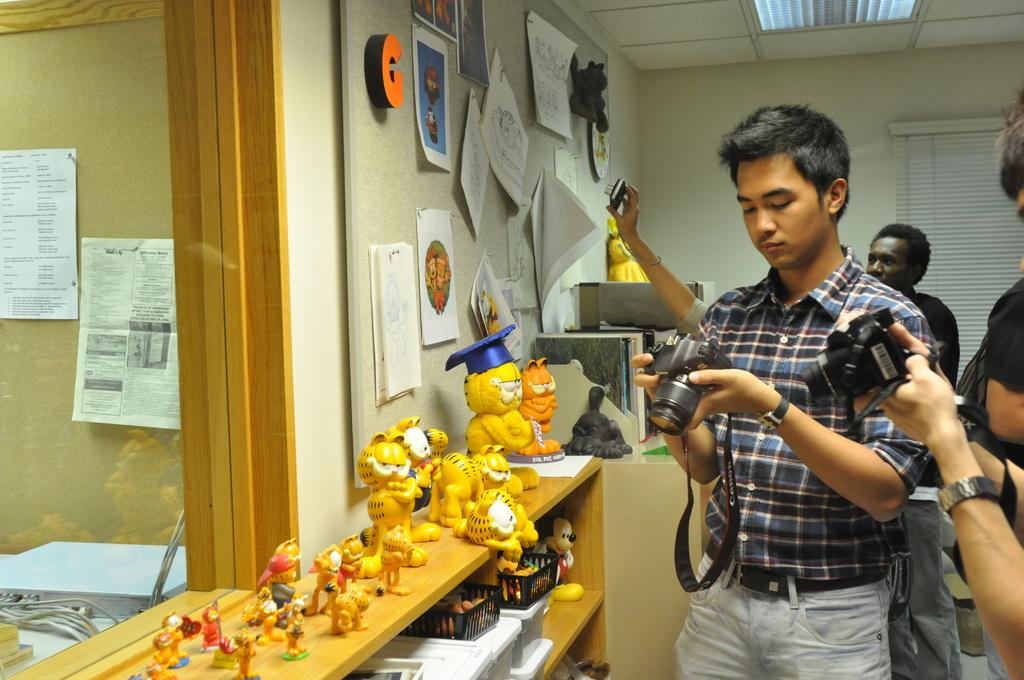What letter is on the wall?
Your answer should be very brief. C. What brand is on the camera strap?
Keep it short and to the point. Canon. 